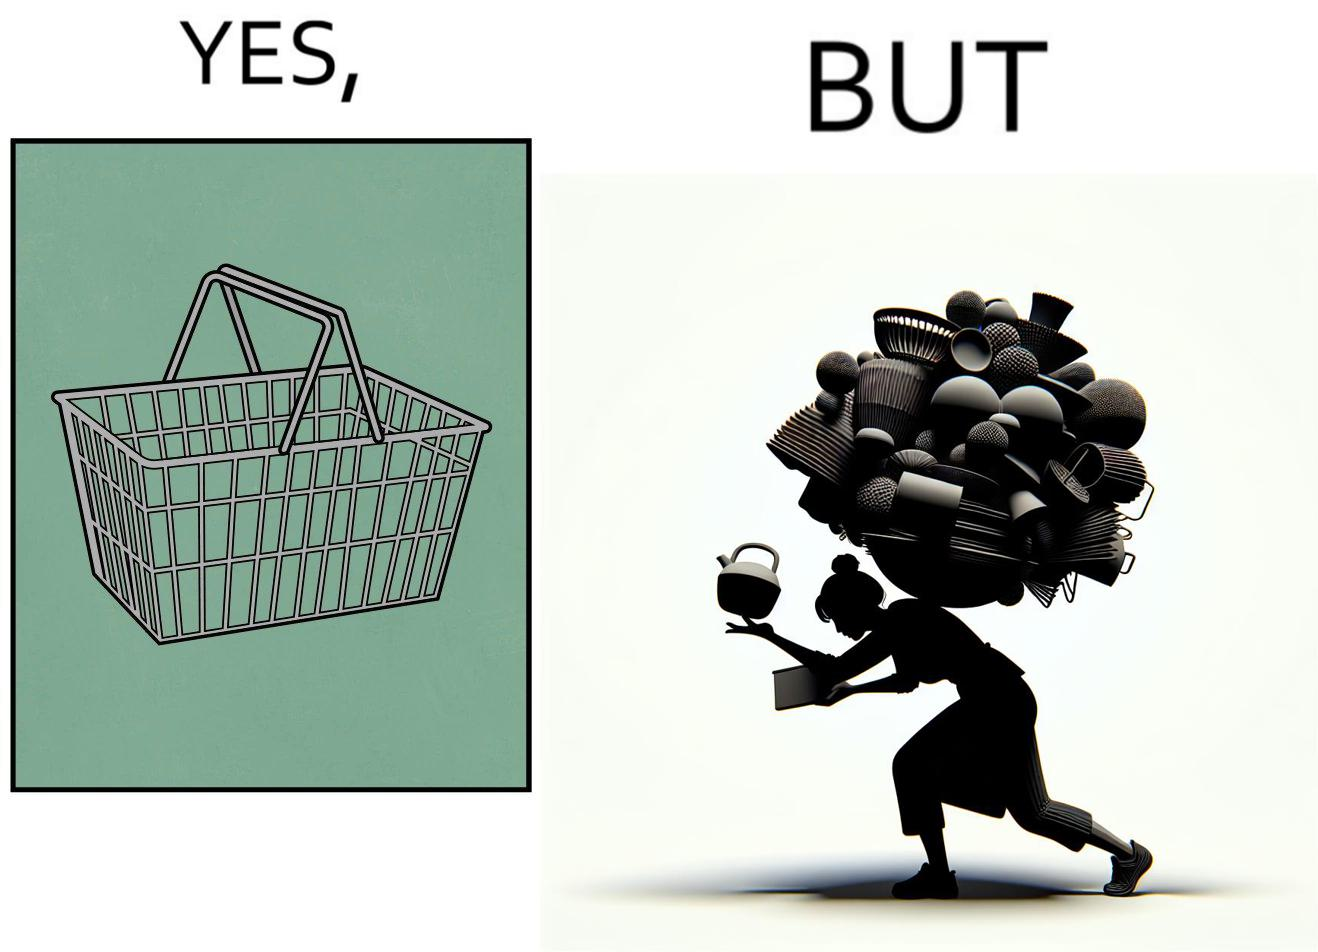What do you see in each half of this image? In the left part of the image: a steel frame basket In the right part of the image: a woman carrying many objects at once trying to hold them, and protecting them from falling off 